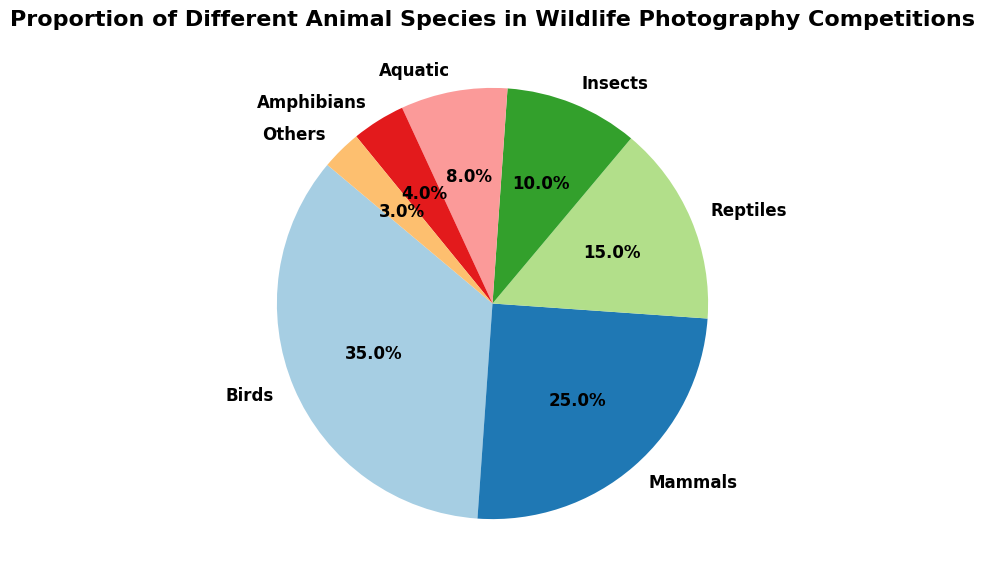What proportion of the species in wildlife photography competitions are amphibians? To find the answer, look at the slice of the pie chart labeled "Amphibians". The chart shows "4%".
Answer: 4% Which species has the highest proportion in wildlife photography competitions? Locate the largest slice in the pie chart, which is labeled "Birds". The slice indicates that Birds have the highest proportion at 35%.
Answer: Birds What is the combined proportion of insects and aquatic species in wildlife photography competitions? Find the slices labeled "Insects" and "Aquatic", then add their proportions: 10% (Insects) + 8% (Aquatic) = 18%.
Answer: 18% Are mammals or reptiles better represented in wildlife photography competitions? Compare the size of the slices labeled "Mammals" and "Reptiles". "Mammals" have a proportion of 25%, while "Reptiles" have 15%. "Mammals" are better represented.
Answer: Mammals How much larger is the proportion of birds compared to reptiles in wildlife photography competitions? First, find the proportions of "Birds" (35%) and "Reptiles" (15%). Then subtract the proportion of "Reptiles" from "Birds": 35% - 15% = 20%.
Answer: 20% What percentage of the chart is made up of species labeled as "Others"? Find the "Others" slice on the pie chart. The chart shows that "Others" account for 3%.
Answer: 3% Is the proportion of amphibians and mammals combined greater than the proportion of birds in wildlife photography competitions? Combine the proportions for "Amphibians" (4%) and "Mammals" (25%): 4% + 25% = 29%. Compare this to the proportion for "Birds" (35%). Since 29% < 35%, the combined proportion is not greater.
Answer: No Which two categories have the closest proportions? Examine the proportions for each species: "Amphibians" (4%), "Reptiles" (15%), "Mammals" (25%), "Birds" (35%), "Insects" (10%), "Aquatic" (8%), and "Others" (3%). "Aquatic" (8%) and "Insects" (10%) have the closest proportions, with a difference of 2%.
Answer: Aquatic and Insects What is the total proportion of mammals, reptiles, and insects combined? Sum the proportions for "Mammals" (25%), "Reptiles" (15%), and "Insects" (10%): 25% + 15% + 10% = 50%.
Answer: 50% Which species proportion is over three times that of amphibians? Find the proportion for "Amphibians" (4%). Identify any species with a proportion more than 12% (three times 4%). "Birds" (35%), "Mammals" (25%), "Reptiles" (15%), and "Insects" (10%) are eligible. The proportions of "Birds", "Mammals", and "Reptiles" are all over three times that of "Amphibians" (4%).
Answer: Birds, Mammals, Reptiles 